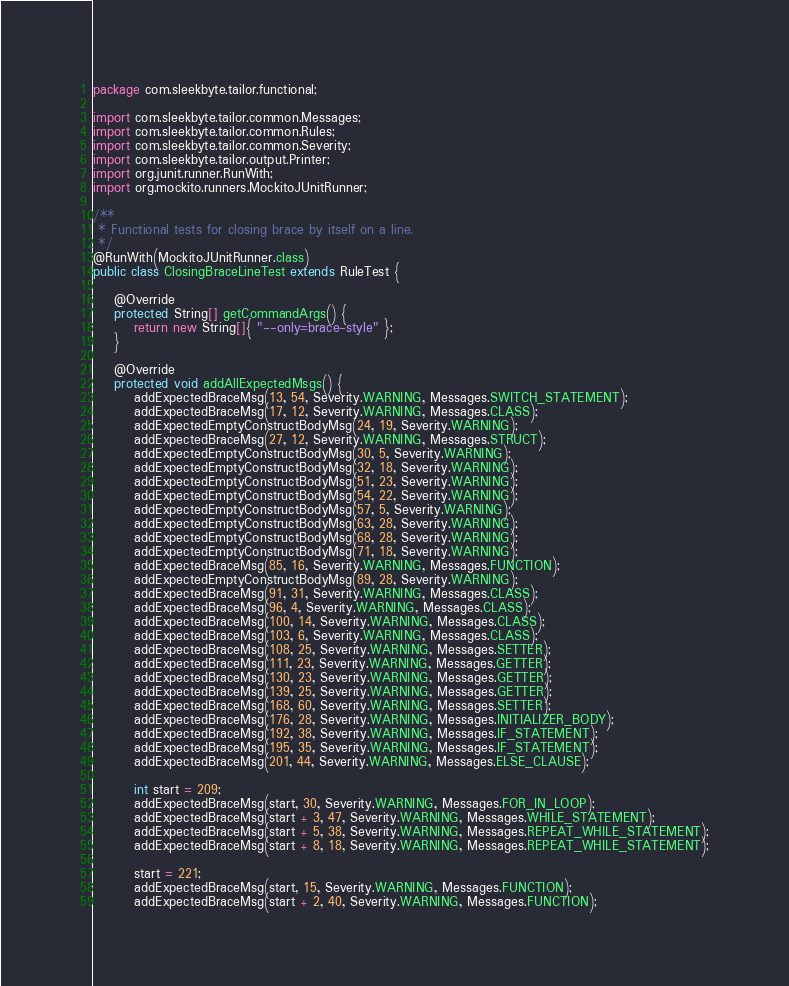<code> <loc_0><loc_0><loc_500><loc_500><_Java_>package com.sleekbyte.tailor.functional;

import com.sleekbyte.tailor.common.Messages;
import com.sleekbyte.tailor.common.Rules;
import com.sleekbyte.tailor.common.Severity;
import com.sleekbyte.tailor.output.Printer;
import org.junit.runner.RunWith;
import org.mockito.runners.MockitoJUnitRunner;

/**
 * Functional tests for closing brace by itself on a line.
 */
@RunWith(MockitoJUnitRunner.class)
public class ClosingBraceLineTest extends RuleTest {

    @Override
    protected String[] getCommandArgs() {
        return new String[]{ "--only=brace-style" };
    }

    @Override
    protected void addAllExpectedMsgs() {
        addExpectedBraceMsg(13, 54, Severity.WARNING, Messages.SWITCH_STATEMENT);
        addExpectedBraceMsg(17, 12, Severity.WARNING, Messages.CLASS);
        addExpectedEmptyConstructBodyMsg(24, 19, Severity.WARNING);
        addExpectedBraceMsg(27, 12, Severity.WARNING, Messages.STRUCT);
        addExpectedEmptyConstructBodyMsg(30, 5, Severity.WARNING);
        addExpectedEmptyConstructBodyMsg(32, 18, Severity.WARNING);
        addExpectedEmptyConstructBodyMsg(51, 23, Severity.WARNING);
        addExpectedEmptyConstructBodyMsg(54, 22, Severity.WARNING);
        addExpectedEmptyConstructBodyMsg(57, 5, Severity.WARNING);
        addExpectedEmptyConstructBodyMsg(63, 28, Severity.WARNING);
        addExpectedEmptyConstructBodyMsg(68, 28, Severity.WARNING);
        addExpectedEmptyConstructBodyMsg(71, 18, Severity.WARNING);
        addExpectedBraceMsg(85, 16, Severity.WARNING, Messages.FUNCTION);
        addExpectedEmptyConstructBodyMsg(89, 28, Severity.WARNING);
        addExpectedBraceMsg(91, 31, Severity.WARNING, Messages.CLASS);
        addExpectedBraceMsg(96, 4, Severity.WARNING, Messages.CLASS);
        addExpectedBraceMsg(100, 14, Severity.WARNING, Messages.CLASS);
        addExpectedBraceMsg(103, 6, Severity.WARNING, Messages.CLASS);
        addExpectedBraceMsg(108, 25, Severity.WARNING, Messages.SETTER);
        addExpectedBraceMsg(111, 23, Severity.WARNING, Messages.GETTER);
        addExpectedBraceMsg(130, 23, Severity.WARNING, Messages.GETTER);
        addExpectedBraceMsg(139, 25, Severity.WARNING, Messages.GETTER);
        addExpectedBraceMsg(168, 60, Severity.WARNING, Messages.SETTER);
        addExpectedBraceMsg(176, 28, Severity.WARNING, Messages.INITIALIZER_BODY);
        addExpectedBraceMsg(192, 38, Severity.WARNING, Messages.IF_STATEMENT);
        addExpectedBraceMsg(195, 35, Severity.WARNING, Messages.IF_STATEMENT);
        addExpectedBraceMsg(201, 44, Severity.WARNING, Messages.ELSE_CLAUSE);

        int start = 209;
        addExpectedBraceMsg(start, 30, Severity.WARNING, Messages.FOR_IN_LOOP);
        addExpectedBraceMsg(start + 3, 47, Severity.WARNING, Messages.WHILE_STATEMENT);
        addExpectedBraceMsg(start + 5, 38, Severity.WARNING, Messages.REPEAT_WHILE_STATEMENT);
        addExpectedBraceMsg(start + 8, 18, Severity.WARNING, Messages.REPEAT_WHILE_STATEMENT);

        start = 221;
        addExpectedBraceMsg(start, 15, Severity.WARNING, Messages.FUNCTION);
        addExpectedBraceMsg(start + 2, 40, Severity.WARNING, Messages.FUNCTION);</code> 